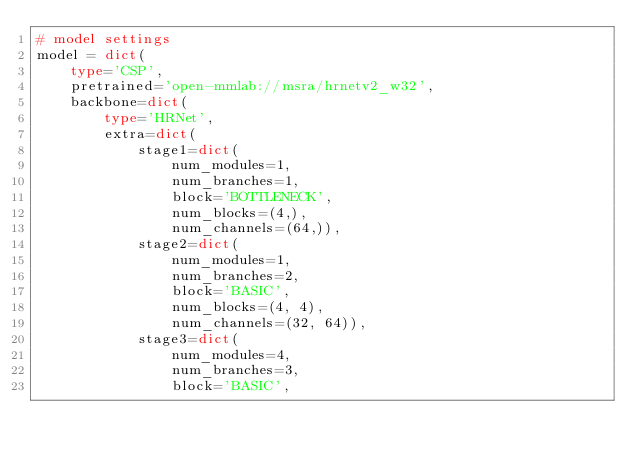Convert code to text. <code><loc_0><loc_0><loc_500><loc_500><_Python_># model settings
model = dict(
    type='CSP',
    pretrained='open-mmlab://msra/hrnetv2_w32',
    backbone=dict(
        type='HRNet',
        extra=dict(
            stage1=dict(
                num_modules=1,
                num_branches=1,
                block='BOTTLENECK',
                num_blocks=(4,),
                num_channels=(64,)),
            stage2=dict(
                num_modules=1,
                num_branches=2,
                block='BASIC',
                num_blocks=(4, 4),
                num_channels=(32, 64)),
            stage3=dict(
                num_modules=4,
                num_branches=3,
                block='BASIC',</code> 